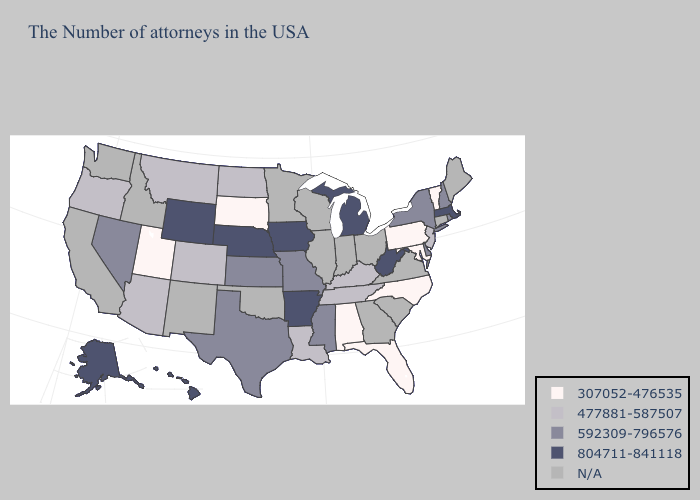Does Tennessee have the lowest value in the USA?
Concise answer only. No. Which states hav the highest value in the Northeast?
Concise answer only. Massachusetts. What is the lowest value in states that border New Jersey?
Answer briefly. 307052-476535. What is the highest value in the South ?
Write a very short answer. 804711-841118. What is the value of Maine?
Be succinct. N/A. Name the states that have a value in the range 477881-587507?
Be succinct. New Jersey, Kentucky, Tennessee, Louisiana, North Dakota, Colorado, Montana, Arizona, Oregon. Which states have the lowest value in the USA?
Answer briefly. Vermont, Maryland, Pennsylvania, North Carolina, Florida, Alabama, South Dakota, Utah. What is the lowest value in the South?
Give a very brief answer. 307052-476535. Which states hav the highest value in the West?
Give a very brief answer. Wyoming, Alaska, Hawaii. Does the first symbol in the legend represent the smallest category?
Be succinct. Yes. Does the first symbol in the legend represent the smallest category?
Quick response, please. Yes. What is the value of Louisiana?
Concise answer only. 477881-587507. Name the states that have a value in the range 307052-476535?
Quick response, please. Vermont, Maryland, Pennsylvania, North Carolina, Florida, Alabama, South Dakota, Utah. 